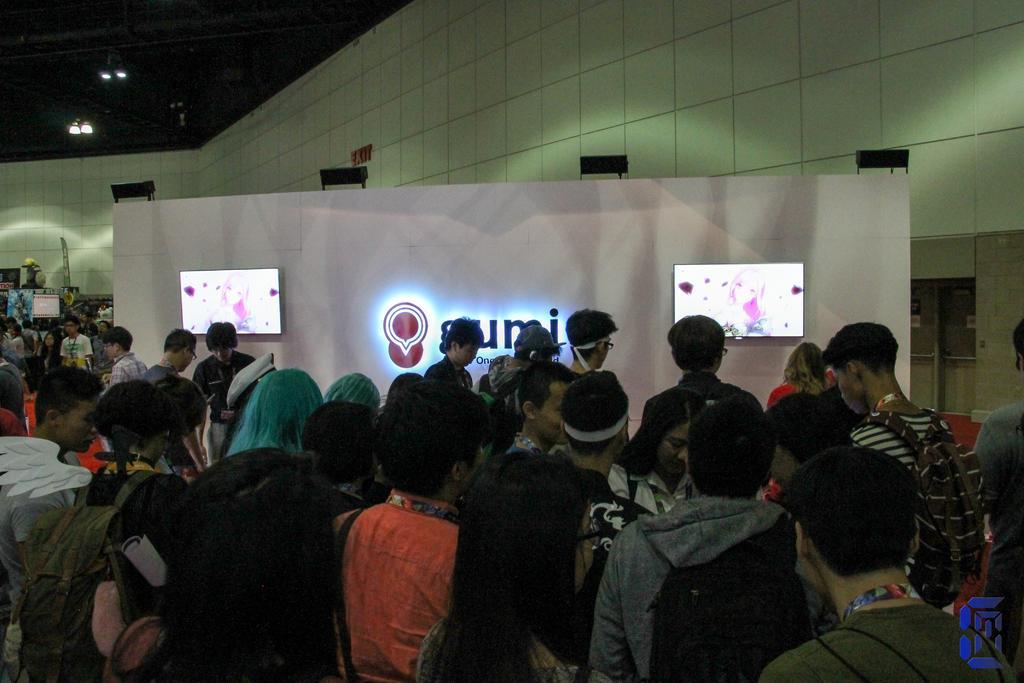In one or two sentences, can you explain what this image depicts? In this image we can see some people are standing in a room and there is a board in the middle with two led tv screens and in the background, we can see the wall. 